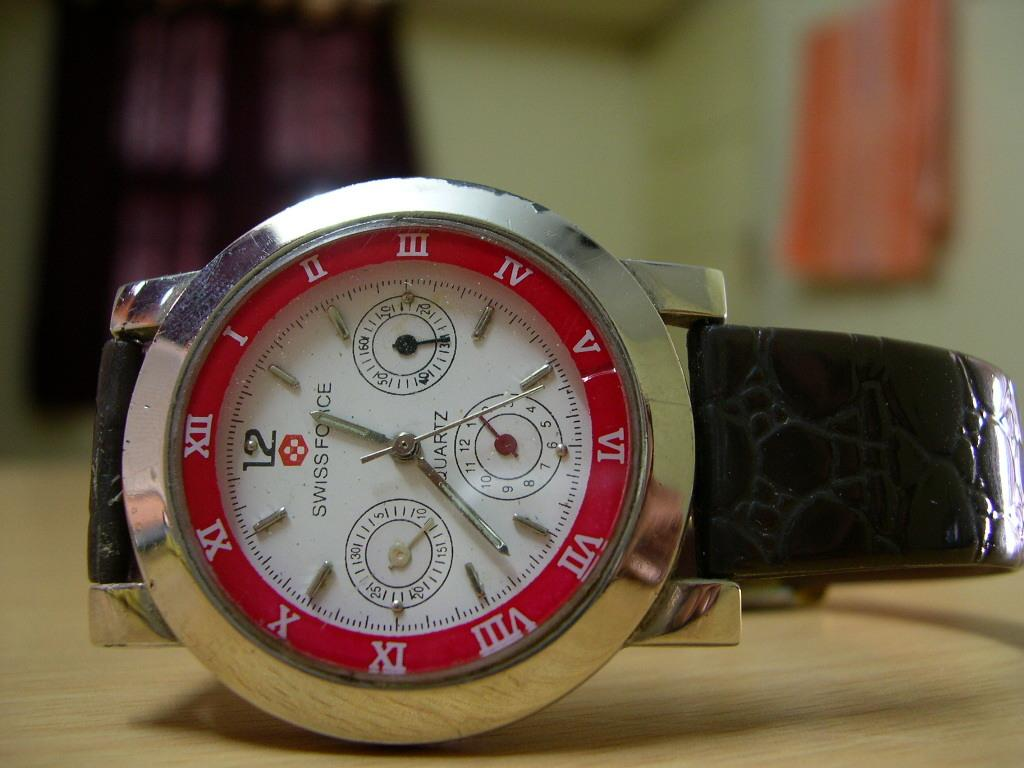<image>
Write a terse but informative summary of the picture. A Swiss Force watch has a white face. 